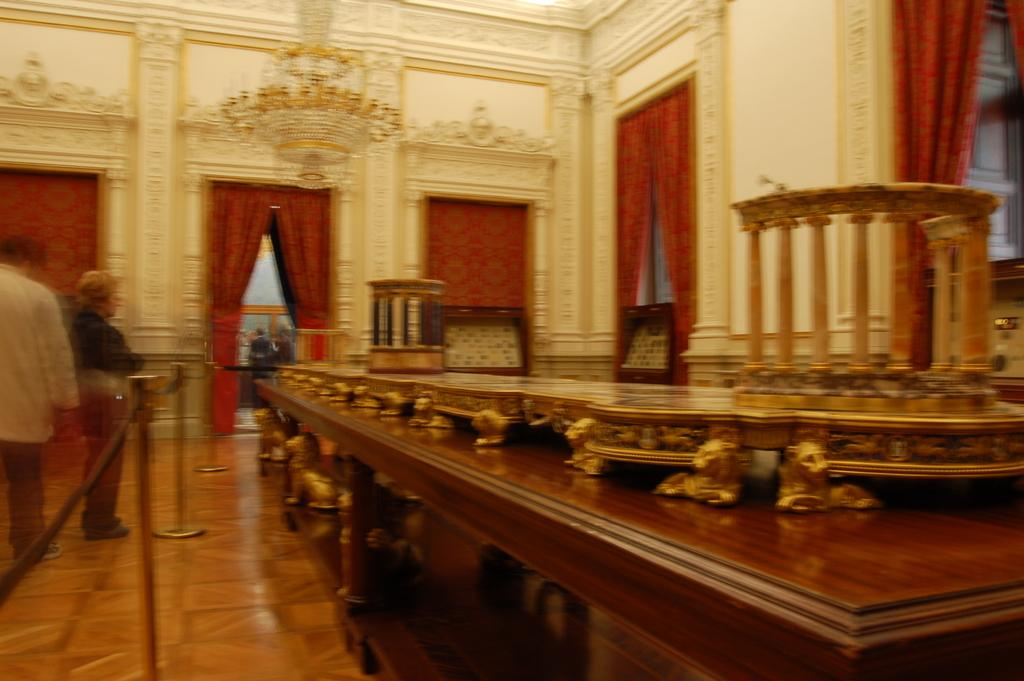What type of furniture is present in the image? There is a desk-like object in the image. What is placed on the desk-like object? There is an object on the desk-like object. What type of architectural feature can be seen in the image? There is fencing in the image. Are there any people visible in the image? Yes, there are people in the image. What type of window treatment is present in the image? There are curtains in the image. What type of soup is being served in the image? There is no soup present in the image. What type of songs are the people singing in the image? There is no indication of people singing in the image. 